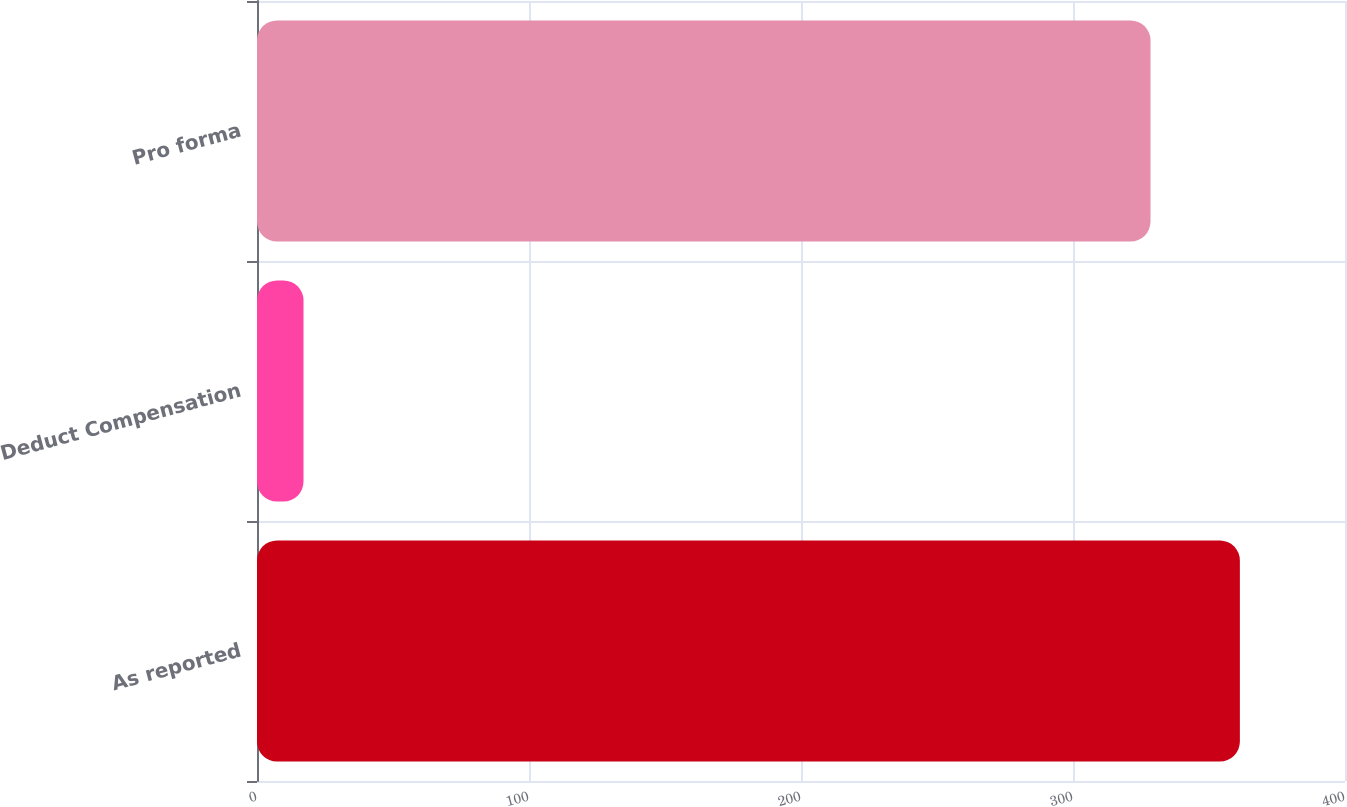Convert chart to OTSL. <chart><loc_0><loc_0><loc_500><loc_500><bar_chart><fcel>As reported<fcel>Deduct Compensation<fcel>Pro forma<nl><fcel>361.35<fcel>17.1<fcel>328.5<nl></chart> 